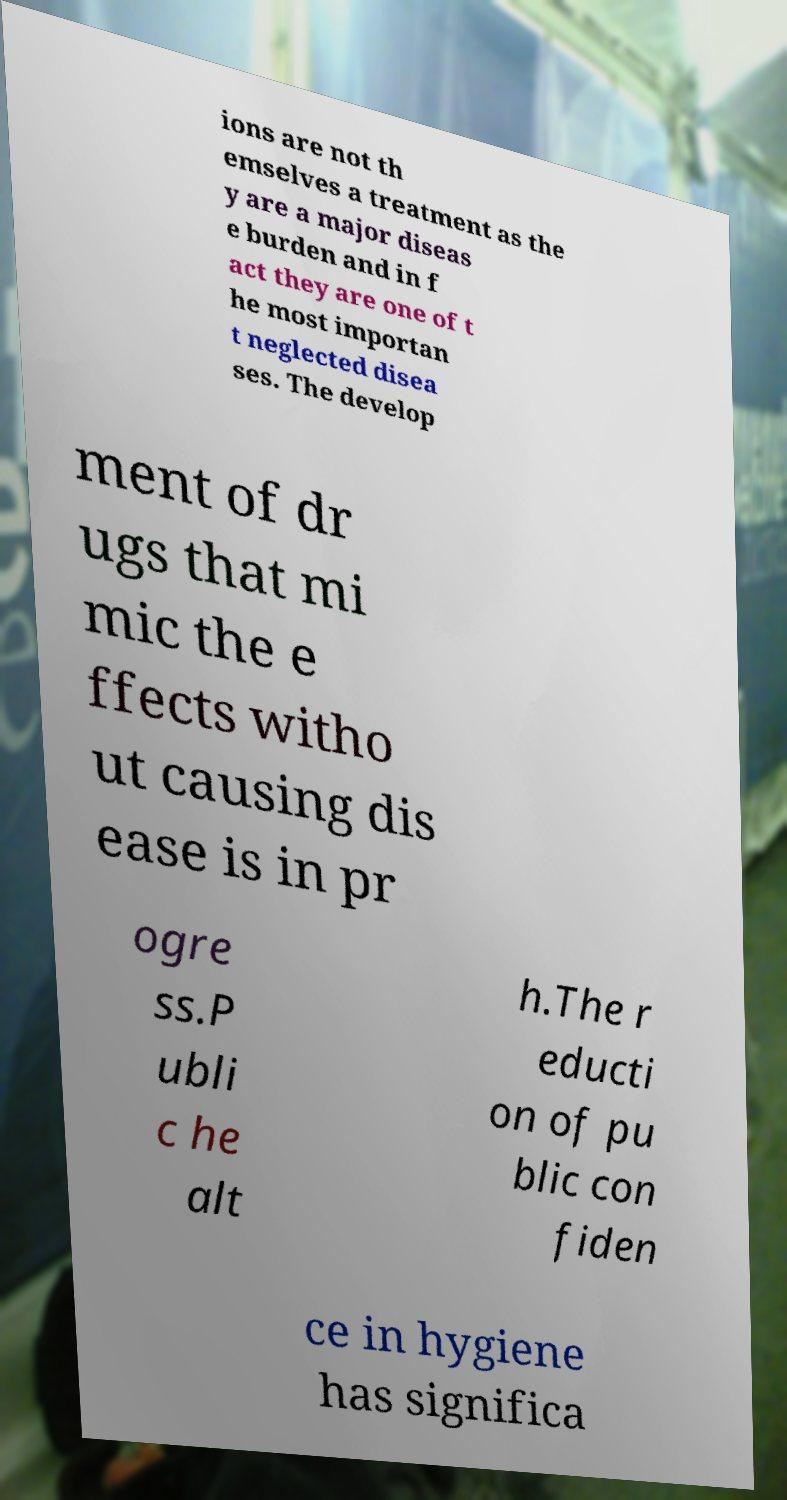There's text embedded in this image that I need extracted. Can you transcribe it verbatim? ions are not th emselves a treatment as the y are a major diseas e burden and in f act they are one of t he most importan t neglected disea ses. The develop ment of dr ugs that mi mic the e ffects witho ut causing dis ease is in pr ogre ss.P ubli c he alt h.The r educti on of pu blic con fiden ce in hygiene has significa 